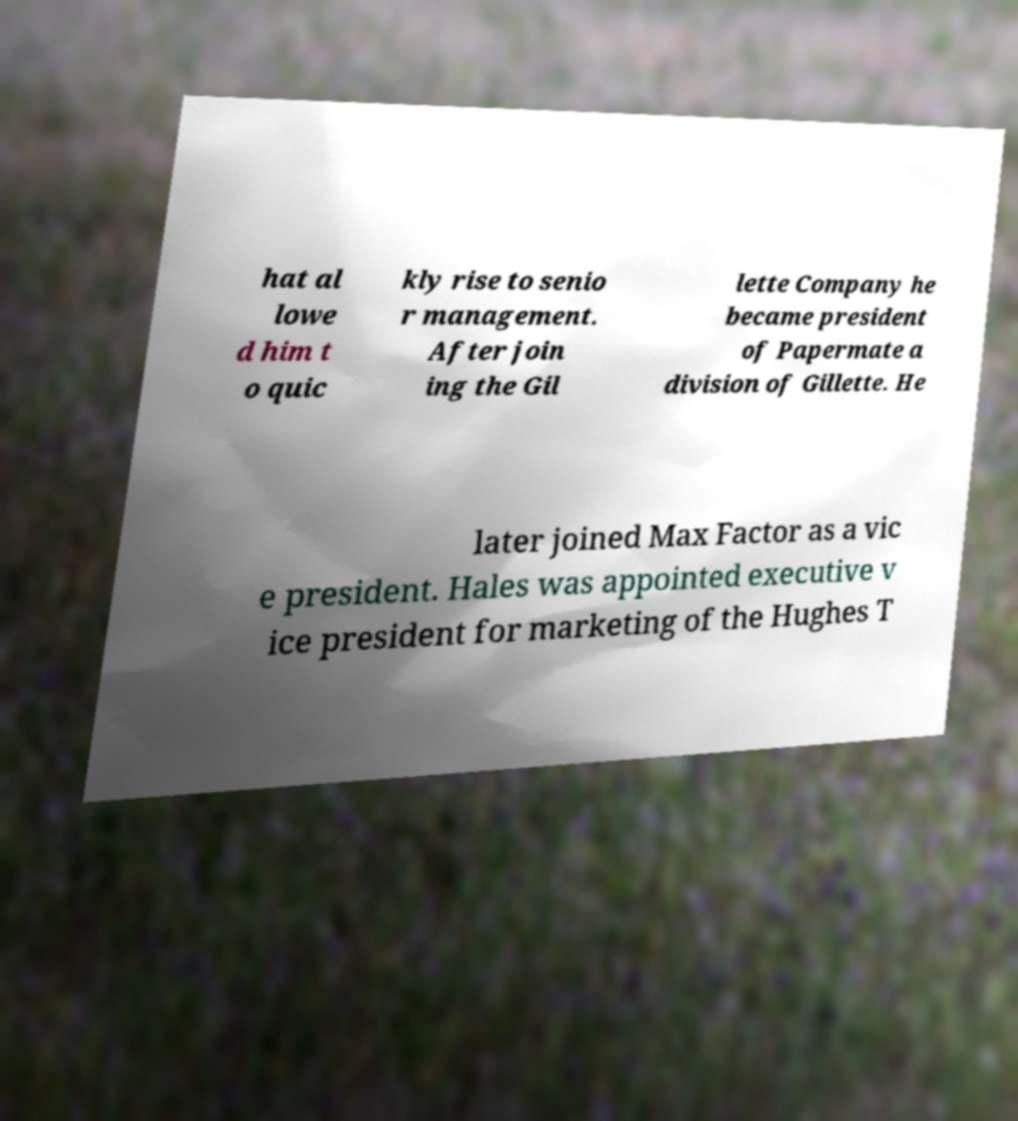There's text embedded in this image that I need extracted. Can you transcribe it verbatim? hat al lowe d him t o quic kly rise to senio r management. After join ing the Gil lette Company he became president of Papermate a division of Gillette. He later joined Max Factor as a vic e president. Hales was appointed executive v ice president for marketing of the Hughes T 